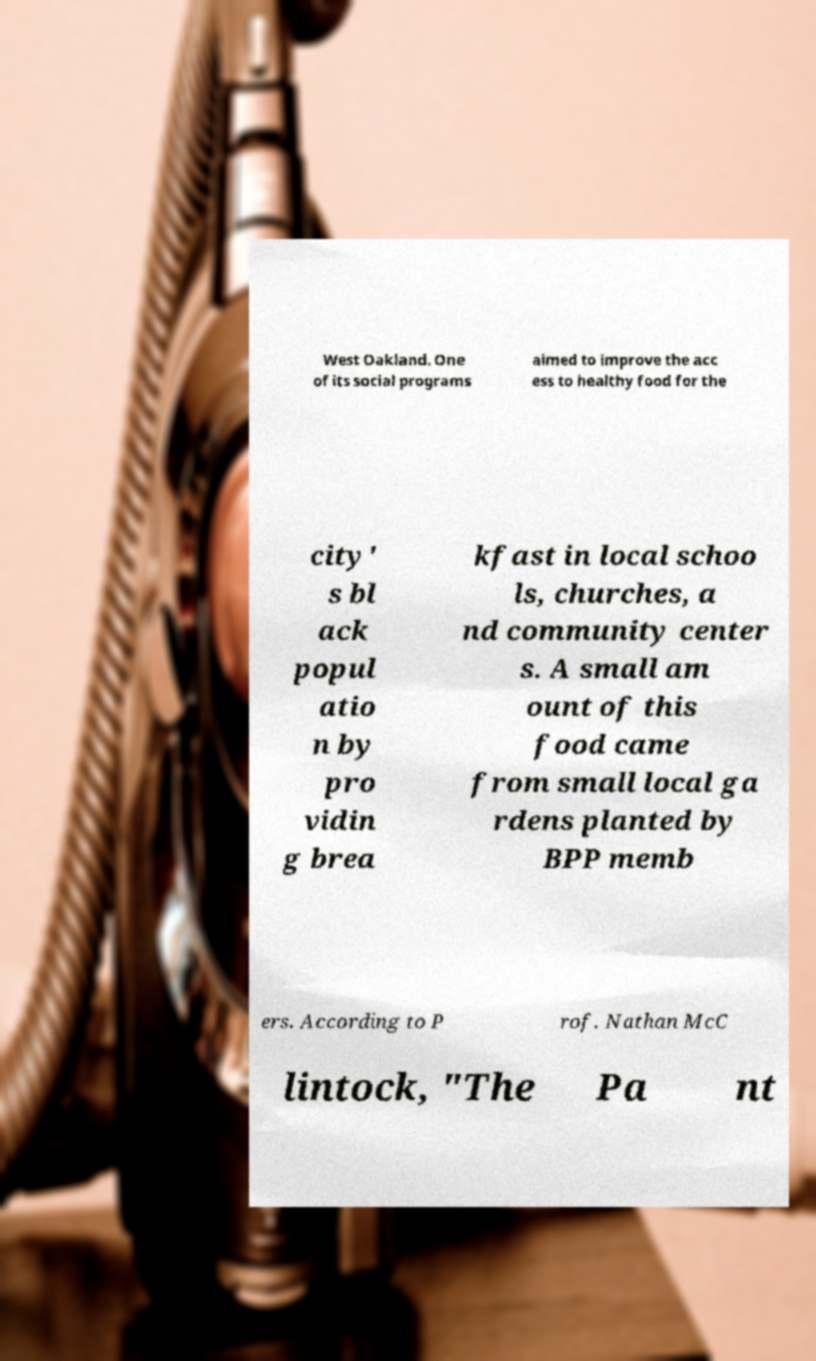Please read and relay the text visible in this image. What does it say? West Oakland. One of its social programs aimed to improve the acc ess to healthy food for the city' s bl ack popul atio n by pro vidin g brea kfast in local schoo ls, churches, a nd community center s. A small am ount of this food came from small local ga rdens planted by BPP memb ers. According to P rof. Nathan McC lintock, "The Pa nt 